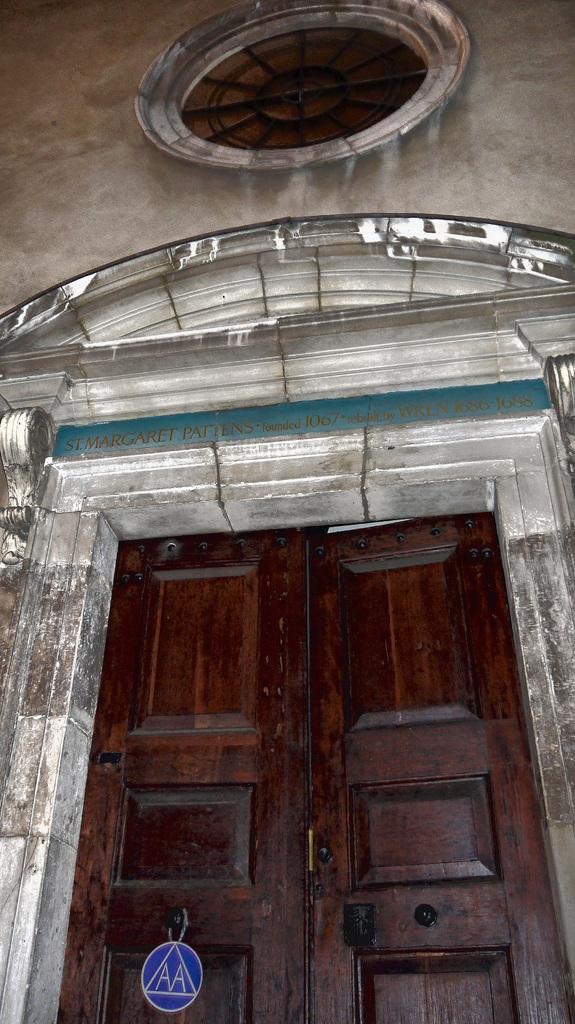What is the main architectural feature in the center of the image? There is a door in the center of the image. What is located above the door? There is a window above the door. What type of structure is visible in the image? There is a wall in the image. What can be seen on the wall? There is text written on the wall. What type of base is supporting the brick structure in the image? There is no brick structure present in the image, and therefore no base is supporting it. 